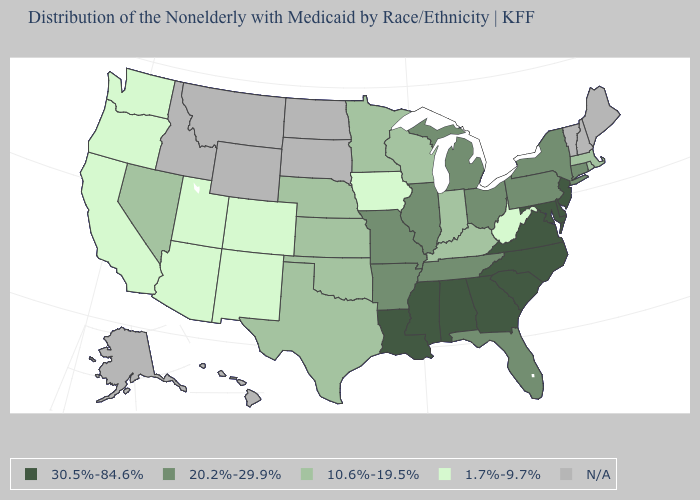What is the value of New York?
Short answer required. 20.2%-29.9%. Does Iowa have the lowest value in the MidWest?
Quick response, please. Yes. Is the legend a continuous bar?
Quick response, please. No. Name the states that have a value in the range 10.6%-19.5%?
Keep it brief. Indiana, Kansas, Kentucky, Massachusetts, Minnesota, Nebraska, Nevada, Oklahoma, Rhode Island, Texas, Wisconsin. What is the value of South Dakota?
Quick response, please. N/A. What is the value of Vermont?
Give a very brief answer. N/A. Among the states that border Tennessee , which have the highest value?
Keep it brief. Alabama, Georgia, Mississippi, North Carolina, Virginia. Does Iowa have the lowest value in the MidWest?
Short answer required. Yes. Among the states that border Oklahoma , does Missouri have the highest value?
Give a very brief answer. Yes. What is the value of North Dakota?
Concise answer only. N/A. What is the value of Pennsylvania?
Concise answer only. 20.2%-29.9%. What is the highest value in the West ?
Answer briefly. 10.6%-19.5%. How many symbols are there in the legend?
Keep it brief. 5. 